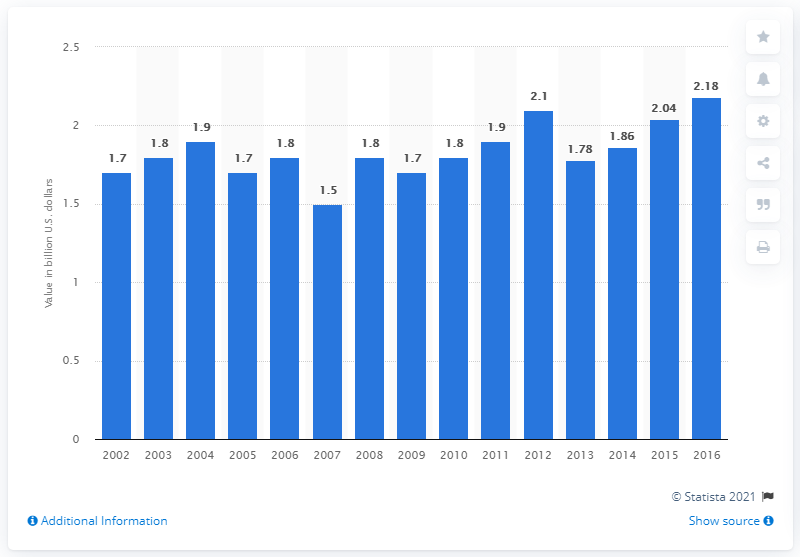List a handful of essential elements in this visual. In the year 2016, the value of chewing gum shipments in the United States was approximately 2.18 billion dollars. 